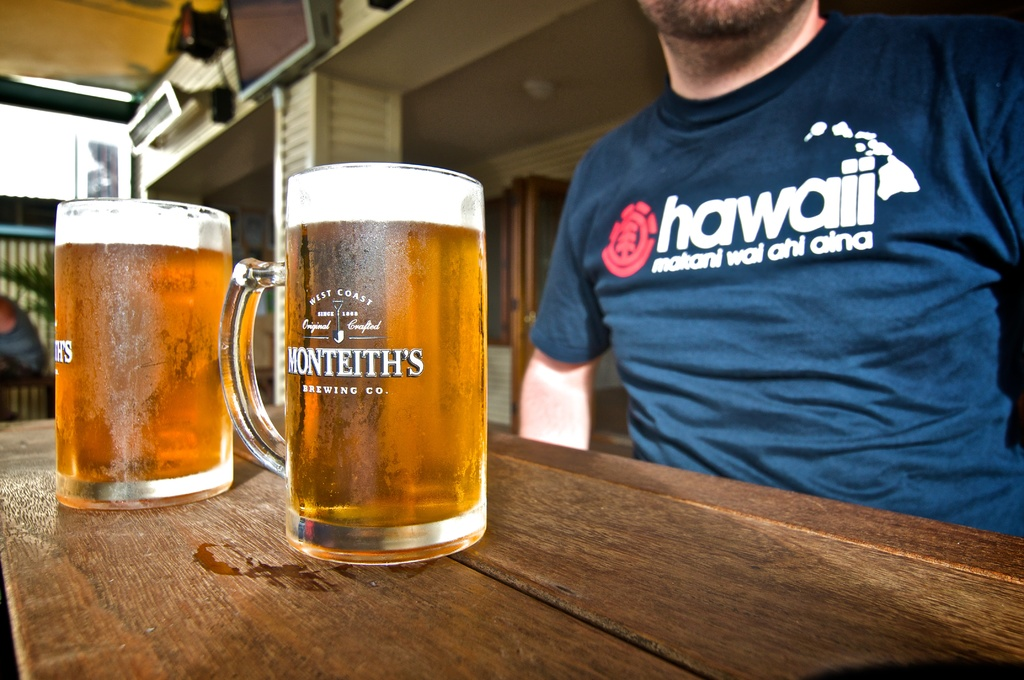Provide a one-sentence caption for the provided image. A relaxed man wearing a 'Hawaii' themed T-shirt enjoys a sunny day at an outdoor setting with two frosty mugs of Montieth's beer on the table. 